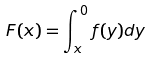<formula> <loc_0><loc_0><loc_500><loc_500>F ( x ) = \int _ { x } ^ { 0 } f ( y ) d y</formula> 